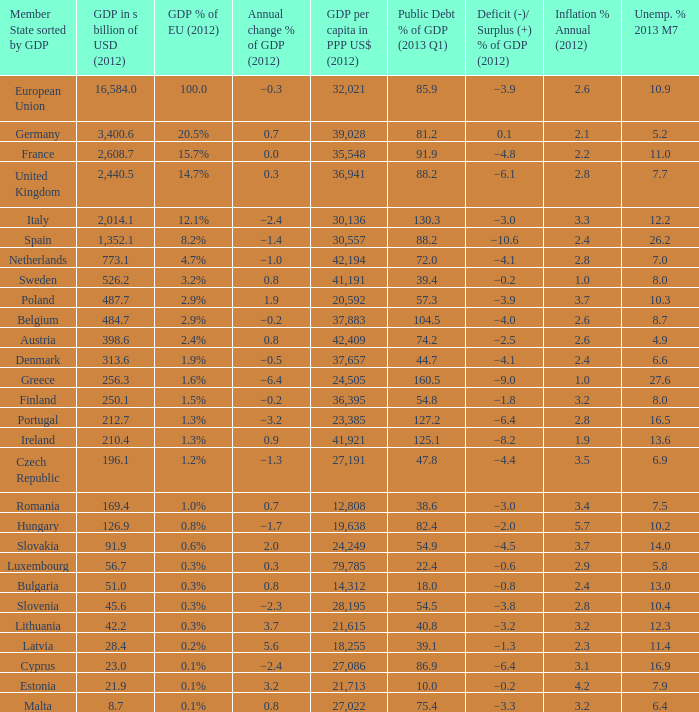What is the largest inflation % annual in 2012 of the country with a public debt % of GDP in 2013 Q1 greater than 88.2 and a GDP % of EU in 2012 of 2.9%? 2.6. 